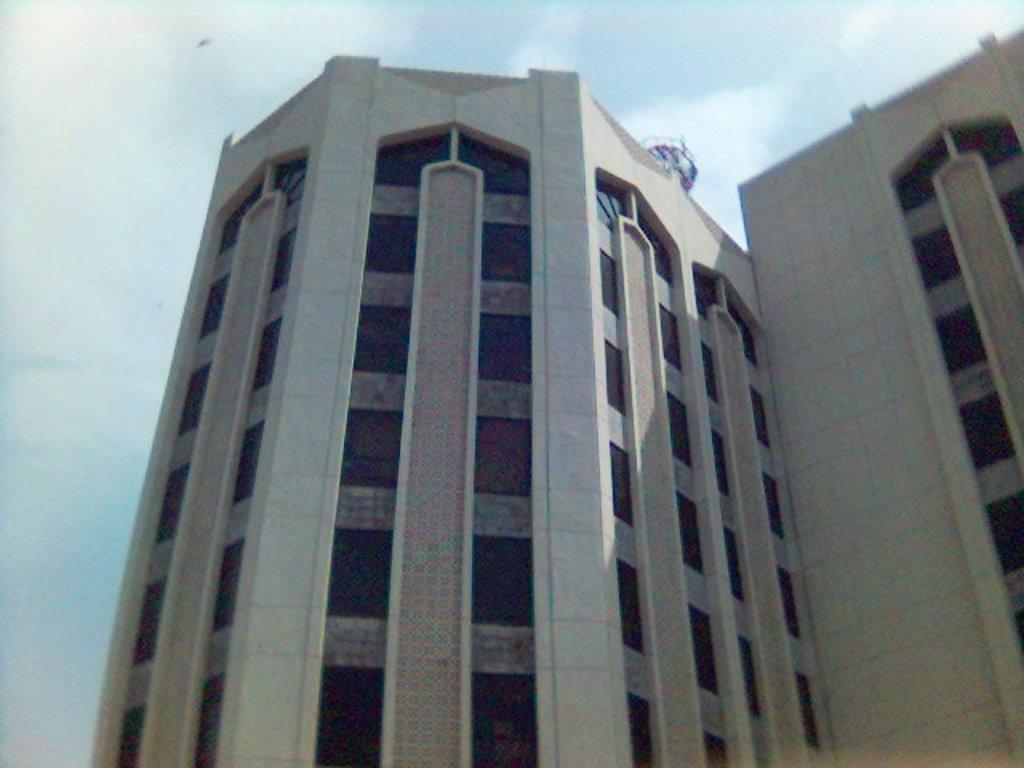Please provide a concise description of this image. Here in this picture we can see a building with windows present on it over there and we can also see the sky is fully covered with clouds over there. 